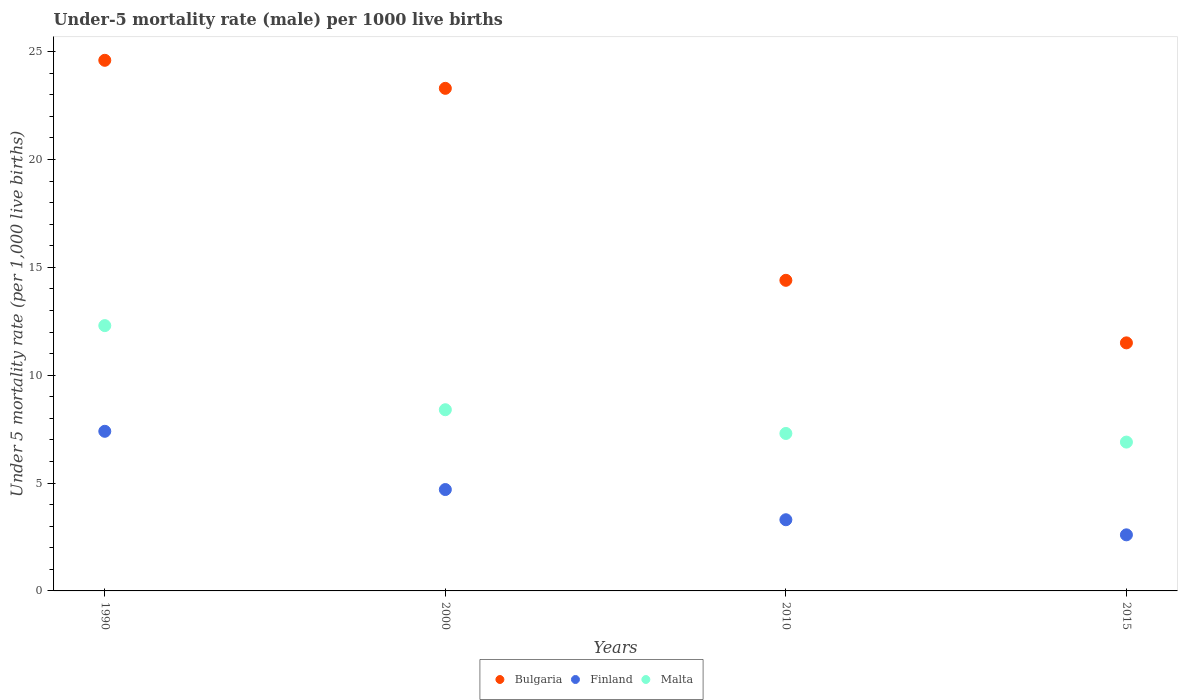Is the number of dotlines equal to the number of legend labels?
Your answer should be very brief. Yes. What is the under-five mortality rate in Finland in 2015?
Your response must be concise. 2.6. Across all years, what is the maximum under-five mortality rate in Bulgaria?
Provide a short and direct response. 24.6. Across all years, what is the minimum under-five mortality rate in Bulgaria?
Ensure brevity in your answer.  11.5. In which year was the under-five mortality rate in Finland maximum?
Your answer should be very brief. 1990. In which year was the under-five mortality rate in Finland minimum?
Your answer should be very brief. 2015. What is the total under-five mortality rate in Bulgaria in the graph?
Your answer should be compact. 73.8. What is the difference between the under-five mortality rate in Finland in 2015 and the under-five mortality rate in Malta in 1990?
Provide a short and direct response. -9.7. What is the average under-five mortality rate in Malta per year?
Provide a short and direct response. 8.73. In the year 1990, what is the difference between the under-five mortality rate in Finland and under-five mortality rate in Bulgaria?
Keep it short and to the point. -17.2. In how many years, is the under-five mortality rate in Finland greater than 22?
Offer a very short reply. 0. What is the ratio of the under-five mortality rate in Bulgaria in 1990 to that in 2010?
Make the answer very short. 1.71. Is the under-five mortality rate in Finland in 1990 less than that in 2000?
Make the answer very short. No. Is the difference between the under-five mortality rate in Finland in 2000 and 2010 greater than the difference between the under-five mortality rate in Bulgaria in 2000 and 2010?
Provide a short and direct response. No. What is the difference between the highest and the second highest under-five mortality rate in Malta?
Give a very brief answer. 3.9. What is the difference between the highest and the lowest under-five mortality rate in Bulgaria?
Offer a terse response. 13.1. Is the sum of the under-five mortality rate in Finland in 1990 and 2015 greater than the maximum under-five mortality rate in Bulgaria across all years?
Ensure brevity in your answer.  No. Is it the case that in every year, the sum of the under-five mortality rate in Malta and under-five mortality rate in Finland  is greater than the under-five mortality rate in Bulgaria?
Your answer should be very brief. No. Does the under-five mortality rate in Malta monotonically increase over the years?
Give a very brief answer. No. Is the under-five mortality rate in Finland strictly less than the under-five mortality rate in Malta over the years?
Your answer should be compact. Yes. How many dotlines are there?
Your answer should be compact. 3. Are the values on the major ticks of Y-axis written in scientific E-notation?
Give a very brief answer. No. Does the graph contain grids?
Your answer should be very brief. No. How many legend labels are there?
Ensure brevity in your answer.  3. What is the title of the graph?
Provide a succinct answer. Under-5 mortality rate (male) per 1000 live births. Does "Russian Federation" appear as one of the legend labels in the graph?
Make the answer very short. No. What is the label or title of the Y-axis?
Your response must be concise. Under 5 mortality rate (per 1,0 live births). What is the Under 5 mortality rate (per 1,000 live births) in Bulgaria in 1990?
Offer a very short reply. 24.6. What is the Under 5 mortality rate (per 1,000 live births) in Malta in 1990?
Make the answer very short. 12.3. What is the Under 5 mortality rate (per 1,000 live births) in Bulgaria in 2000?
Provide a succinct answer. 23.3. What is the Under 5 mortality rate (per 1,000 live births) in Bulgaria in 2010?
Offer a very short reply. 14.4. What is the Under 5 mortality rate (per 1,000 live births) in Malta in 2015?
Offer a terse response. 6.9. Across all years, what is the maximum Under 5 mortality rate (per 1,000 live births) of Bulgaria?
Provide a succinct answer. 24.6. Across all years, what is the maximum Under 5 mortality rate (per 1,000 live births) of Finland?
Keep it short and to the point. 7.4. Across all years, what is the maximum Under 5 mortality rate (per 1,000 live births) of Malta?
Offer a very short reply. 12.3. What is the total Under 5 mortality rate (per 1,000 live births) in Bulgaria in the graph?
Your response must be concise. 73.8. What is the total Under 5 mortality rate (per 1,000 live births) of Malta in the graph?
Make the answer very short. 34.9. What is the difference between the Under 5 mortality rate (per 1,000 live births) of Bulgaria in 1990 and that in 2000?
Offer a very short reply. 1.3. What is the difference between the Under 5 mortality rate (per 1,000 live births) in Bulgaria in 1990 and that in 2010?
Offer a very short reply. 10.2. What is the difference between the Under 5 mortality rate (per 1,000 live births) of Finland in 1990 and that in 2010?
Provide a short and direct response. 4.1. What is the difference between the Under 5 mortality rate (per 1,000 live births) in Malta in 1990 and that in 2010?
Keep it short and to the point. 5. What is the difference between the Under 5 mortality rate (per 1,000 live births) in Bulgaria in 1990 and that in 2015?
Give a very brief answer. 13.1. What is the difference between the Under 5 mortality rate (per 1,000 live births) of Malta in 1990 and that in 2015?
Make the answer very short. 5.4. What is the difference between the Under 5 mortality rate (per 1,000 live births) in Finland in 2000 and that in 2010?
Give a very brief answer. 1.4. What is the difference between the Under 5 mortality rate (per 1,000 live births) of Finland in 2000 and that in 2015?
Your answer should be compact. 2.1. What is the difference between the Under 5 mortality rate (per 1,000 live births) of Bulgaria in 1990 and the Under 5 mortality rate (per 1,000 live births) of Malta in 2000?
Your answer should be compact. 16.2. What is the difference between the Under 5 mortality rate (per 1,000 live births) of Bulgaria in 1990 and the Under 5 mortality rate (per 1,000 live births) of Finland in 2010?
Ensure brevity in your answer.  21.3. What is the difference between the Under 5 mortality rate (per 1,000 live births) of Bulgaria in 1990 and the Under 5 mortality rate (per 1,000 live births) of Malta in 2010?
Ensure brevity in your answer.  17.3. What is the difference between the Under 5 mortality rate (per 1,000 live births) in Bulgaria in 2000 and the Under 5 mortality rate (per 1,000 live births) in Finland in 2010?
Provide a succinct answer. 20. What is the difference between the Under 5 mortality rate (per 1,000 live births) of Bulgaria in 2000 and the Under 5 mortality rate (per 1,000 live births) of Malta in 2010?
Your answer should be very brief. 16. What is the difference between the Under 5 mortality rate (per 1,000 live births) of Bulgaria in 2000 and the Under 5 mortality rate (per 1,000 live births) of Finland in 2015?
Offer a very short reply. 20.7. What is the difference between the Under 5 mortality rate (per 1,000 live births) of Finland in 2000 and the Under 5 mortality rate (per 1,000 live births) of Malta in 2015?
Keep it short and to the point. -2.2. What is the difference between the Under 5 mortality rate (per 1,000 live births) in Bulgaria in 2010 and the Under 5 mortality rate (per 1,000 live births) in Malta in 2015?
Keep it short and to the point. 7.5. What is the difference between the Under 5 mortality rate (per 1,000 live births) in Finland in 2010 and the Under 5 mortality rate (per 1,000 live births) in Malta in 2015?
Your answer should be very brief. -3.6. What is the average Under 5 mortality rate (per 1,000 live births) of Bulgaria per year?
Provide a succinct answer. 18.45. What is the average Under 5 mortality rate (per 1,000 live births) in Malta per year?
Your answer should be compact. 8.72. In the year 1990, what is the difference between the Under 5 mortality rate (per 1,000 live births) of Bulgaria and Under 5 mortality rate (per 1,000 live births) of Finland?
Your answer should be compact. 17.2. In the year 1990, what is the difference between the Under 5 mortality rate (per 1,000 live births) of Finland and Under 5 mortality rate (per 1,000 live births) of Malta?
Your answer should be very brief. -4.9. In the year 2000, what is the difference between the Under 5 mortality rate (per 1,000 live births) in Bulgaria and Under 5 mortality rate (per 1,000 live births) in Malta?
Offer a terse response. 14.9. In the year 2010, what is the difference between the Under 5 mortality rate (per 1,000 live births) in Finland and Under 5 mortality rate (per 1,000 live births) in Malta?
Your answer should be very brief. -4. What is the ratio of the Under 5 mortality rate (per 1,000 live births) of Bulgaria in 1990 to that in 2000?
Make the answer very short. 1.06. What is the ratio of the Under 5 mortality rate (per 1,000 live births) of Finland in 1990 to that in 2000?
Your answer should be compact. 1.57. What is the ratio of the Under 5 mortality rate (per 1,000 live births) of Malta in 1990 to that in 2000?
Keep it short and to the point. 1.46. What is the ratio of the Under 5 mortality rate (per 1,000 live births) in Bulgaria in 1990 to that in 2010?
Make the answer very short. 1.71. What is the ratio of the Under 5 mortality rate (per 1,000 live births) in Finland in 1990 to that in 2010?
Offer a terse response. 2.24. What is the ratio of the Under 5 mortality rate (per 1,000 live births) in Malta in 1990 to that in 2010?
Offer a terse response. 1.68. What is the ratio of the Under 5 mortality rate (per 1,000 live births) in Bulgaria in 1990 to that in 2015?
Offer a very short reply. 2.14. What is the ratio of the Under 5 mortality rate (per 1,000 live births) of Finland in 1990 to that in 2015?
Make the answer very short. 2.85. What is the ratio of the Under 5 mortality rate (per 1,000 live births) in Malta in 1990 to that in 2015?
Offer a very short reply. 1.78. What is the ratio of the Under 5 mortality rate (per 1,000 live births) in Bulgaria in 2000 to that in 2010?
Make the answer very short. 1.62. What is the ratio of the Under 5 mortality rate (per 1,000 live births) of Finland in 2000 to that in 2010?
Offer a very short reply. 1.42. What is the ratio of the Under 5 mortality rate (per 1,000 live births) of Malta in 2000 to that in 2010?
Ensure brevity in your answer.  1.15. What is the ratio of the Under 5 mortality rate (per 1,000 live births) in Bulgaria in 2000 to that in 2015?
Offer a terse response. 2.03. What is the ratio of the Under 5 mortality rate (per 1,000 live births) in Finland in 2000 to that in 2015?
Make the answer very short. 1.81. What is the ratio of the Under 5 mortality rate (per 1,000 live births) in Malta in 2000 to that in 2015?
Your response must be concise. 1.22. What is the ratio of the Under 5 mortality rate (per 1,000 live births) in Bulgaria in 2010 to that in 2015?
Keep it short and to the point. 1.25. What is the ratio of the Under 5 mortality rate (per 1,000 live births) of Finland in 2010 to that in 2015?
Offer a terse response. 1.27. What is the ratio of the Under 5 mortality rate (per 1,000 live births) of Malta in 2010 to that in 2015?
Make the answer very short. 1.06. What is the difference between the highest and the second highest Under 5 mortality rate (per 1,000 live births) in Bulgaria?
Offer a very short reply. 1.3. What is the difference between the highest and the second highest Under 5 mortality rate (per 1,000 live births) in Finland?
Make the answer very short. 2.7. What is the difference between the highest and the second highest Under 5 mortality rate (per 1,000 live births) of Malta?
Offer a terse response. 3.9. 